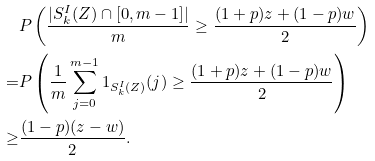<formula> <loc_0><loc_0><loc_500><loc_500>& P \left ( \frac { | S _ { k } ^ { I } ( Z ) \cap [ 0 , m - 1 ] | } { m } \geq \frac { ( 1 + p ) z + ( 1 - p ) w } { 2 } \right ) \\ = & P \left ( \frac { 1 } { m } \sum _ { j = 0 } ^ { m - 1 } 1 _ { S _ { k } ^ { I } ( Z ) } ( j ) \geq \frac { ( 1 + p ) z + ( 1 - p ) w } { 2 } \right ) \\ \geq & \frac { ( 1 - p ) ( z - w ) } { 2 } .</formula> 